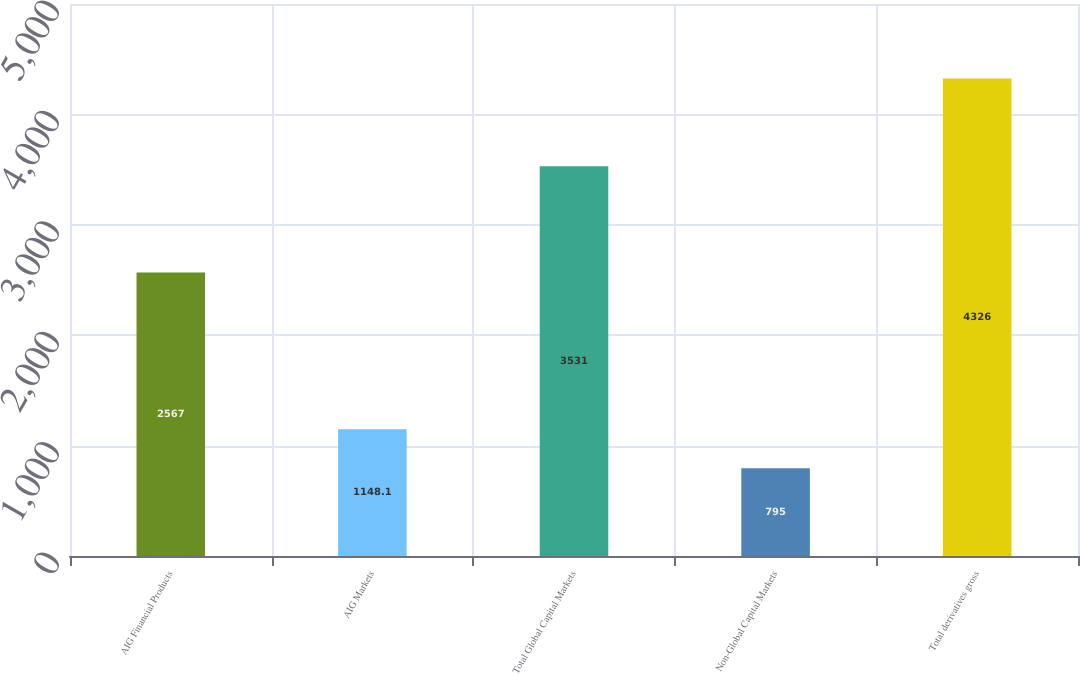<chart> <loc_0><loc_0><loc_500><loc_500><bar_chart><fcel>AIG Financial Products<fcel>AIG Markets<fcel>Total Global Capital Markets<fcel>Non-Global Capital Markets<fcel>Total derivatives gross<nl><fcel>2567<fcel>1148.1<fcel>3531<fcel>795<fcel>4326<nl></chart> 